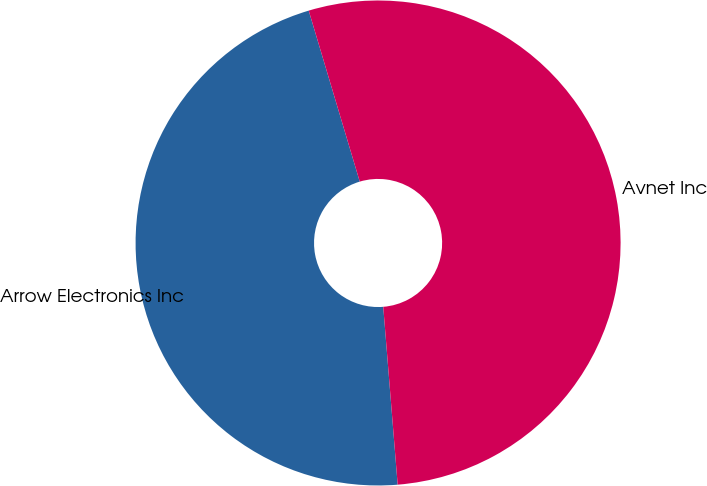Convert chart. <chart><loc_0><loc_0><loc_500><loc_500><pie_chart><fcel>Arrow Electronics Inc<fcel>Avnet Inc<nl><fcel>46.67%<fcel>53.33%<nl></chart> 